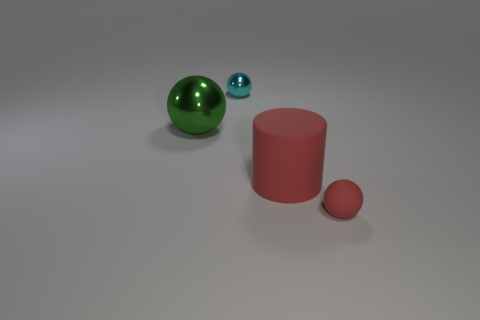Subtract all tiny red balls. How many balls are left? 2 Add 2 big red rubber objects. How many objects exist? 6 Subtract all red balls. How many balls are left? 2 Subtract 1 cylinders. How many cylinders are left? 0 Subtract all cylinders. How many objects are left? 3 Add 1 tiny matte spheres. How many tiny matte spheres exist? 2 Subtract 0 gray blocks. How many objects are left? 4 Subtract all brown balls. Subtract all yellow cylinders. How many balls are left? 3 Subtract all red cylinders. How many gray balls are left? 0 Subtract all tiny gray things. Subtract all red rubber cylinders. How many objects are left? 3 